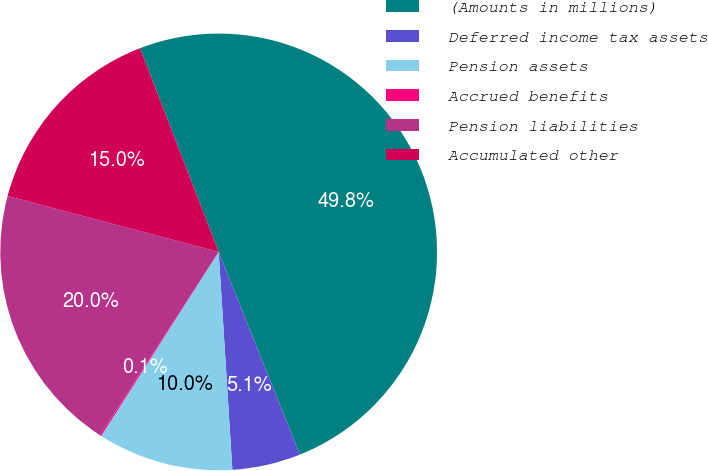Convert chart to OTSL. <chart><loc_0><loc_0><loc_500><loc_500><pie_chart><fcel>(Amounts in millions)<fcel>Deferred income tax assets<fcel>Pension assets<fcel>Accrued benefits<fcel>Pension liabilities<fcel>Accumulated other<nl><fcel>49.8%<fcel>5.07%<fcel>10.04%<fcel>0.1%<fcel>19.98%<fcel>15.01%<nl></chart> 